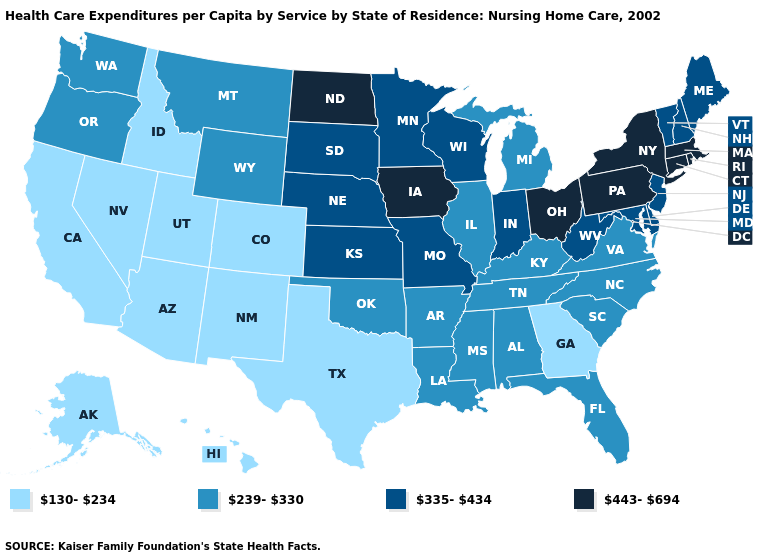What is the value of Colorado?
Concise answer only. 130-234. Name the states that have a value in the range 239-330?
Write a very short answer. Alabama, Arkansas, Florida, Illinois, Kentucky, Louisiana, Michigan, Mississippi, Montana, North Carolina, Oklahoma, Oregon, South Carolina, Tennessee, Virginia, Washington, Wyoming. Does the map have missing data?
Write a very short answer. No. Which states have the lowest value in the USA?
Keep it brief. Alaska, Arizona, California, Colorado, Georgia, Hawaii, Idaho, Nevada, New Mexico, Texas, Utah. What is the value of Wisconsin?
Be succinct. 335-434. Does the map have missing data?
Keep it brief. No. What is the value of Iowa?
Be succinct. 443-694. Which states have the lowest value in the South?
Quick response, please. Georgia, Texas. Among the states that border North Dakota , does South Dakota have the highest value?
Write a very short answer. Yes. Does the first symbol in the legend represent the smallest category?
Quick response, please. Yes. What is the value of North Dakota?
Quick response, please. 443-694. What is the value of New Hampshire?
Short answer required. 335-434. Does Texas have the highest value in the USA?
Short answer required. No. Does New York have the highest value in the USA?
Give a very brief answer. Yes. What is the highest value in states that border North Dakota?
Keep it brief. 335-434. 